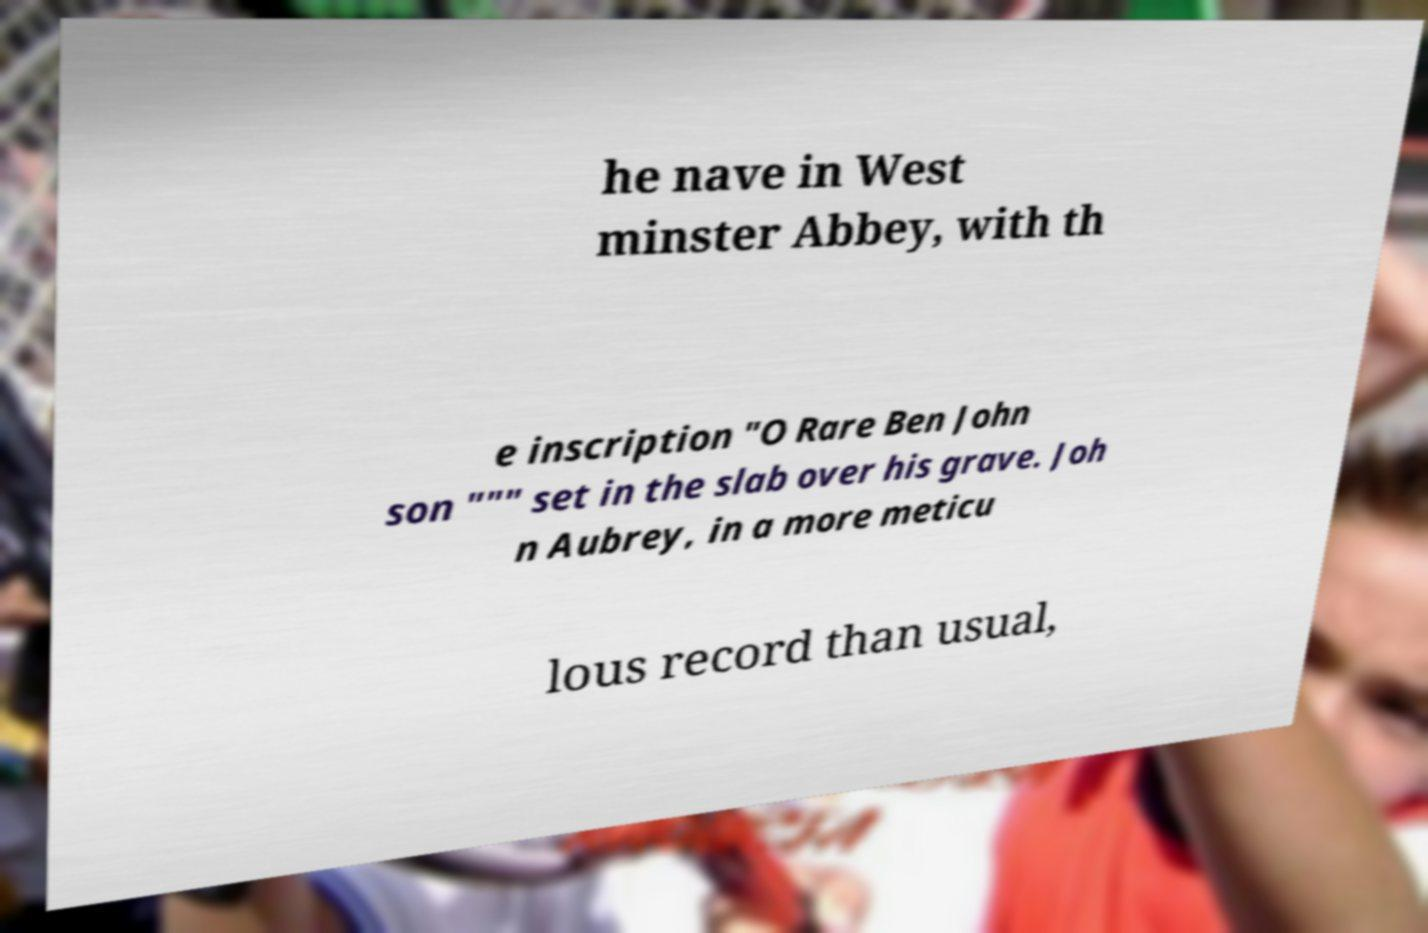Can you accurately transcribe the text from the provided image for me? he nave in West minster Abbey, with th e inscription "O Rare Ben John son """ set in the slab over his grave. Joh n Aubrey, in a more meticu lous record than usual, 